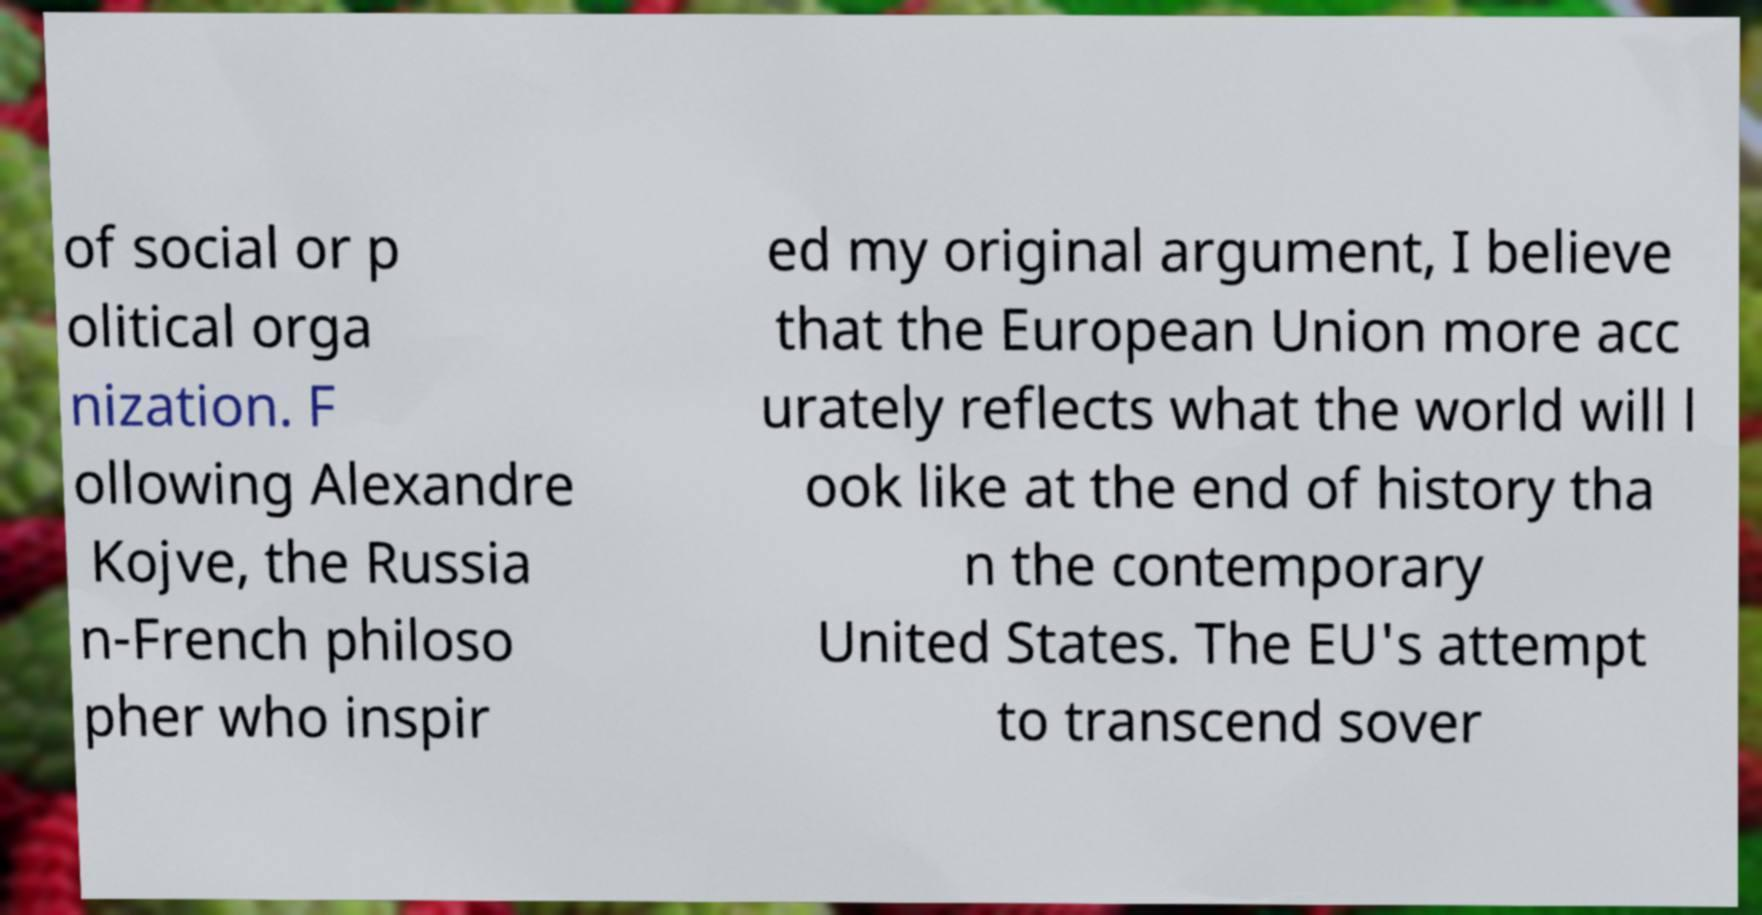Please read and relay the text visible in this image. What does it say? of social or p olitical orga nization. F ollowing Alexandre Kojve, the Russia n-French philoso pher who inspir ed my original argument, I believe that the European Union more acc urately reflects what the world will l ook like at the end of history tha n the contemporary United States. The EU's attempt to transcend sover 